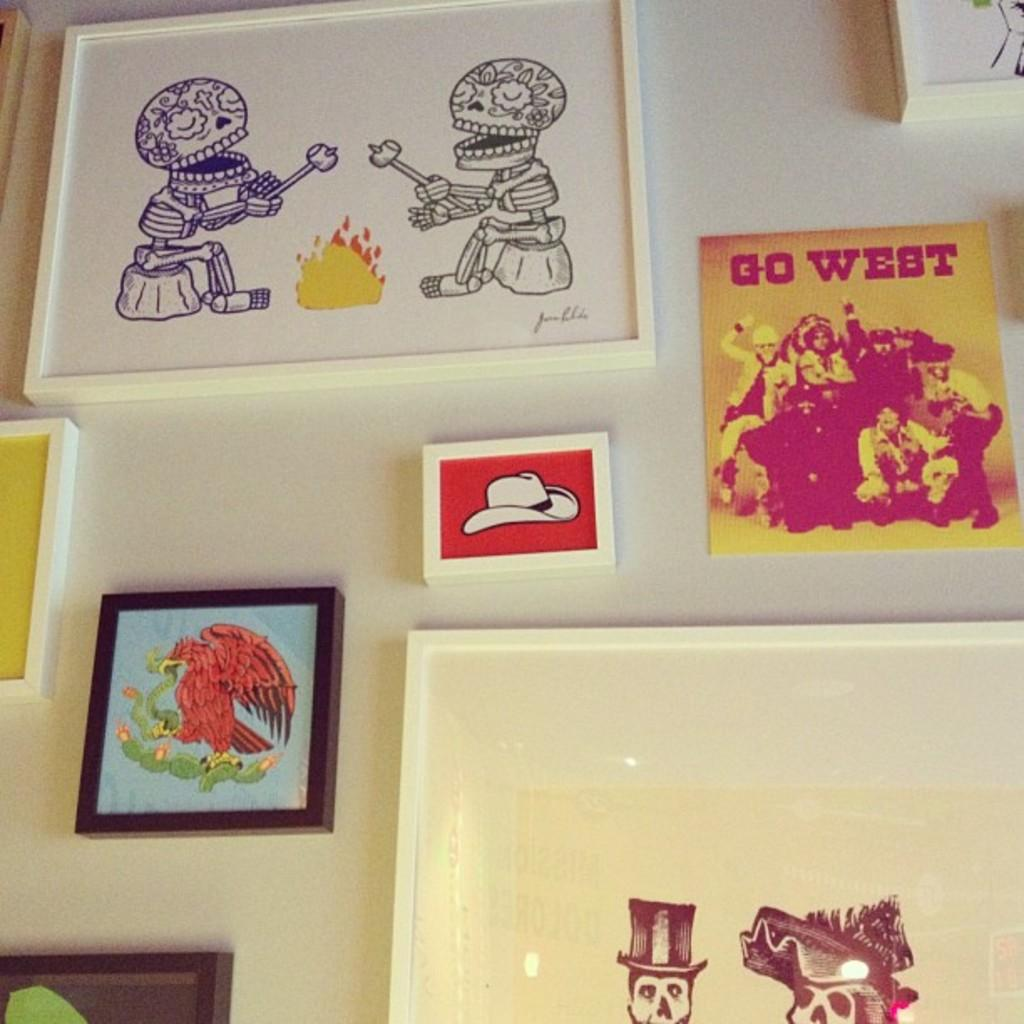<image>
Share a concise interpretation of the image provided. Frames hanging on a wall displaying a cowboy hat with a red background, Go West, and two skeletons sitting at a fire 